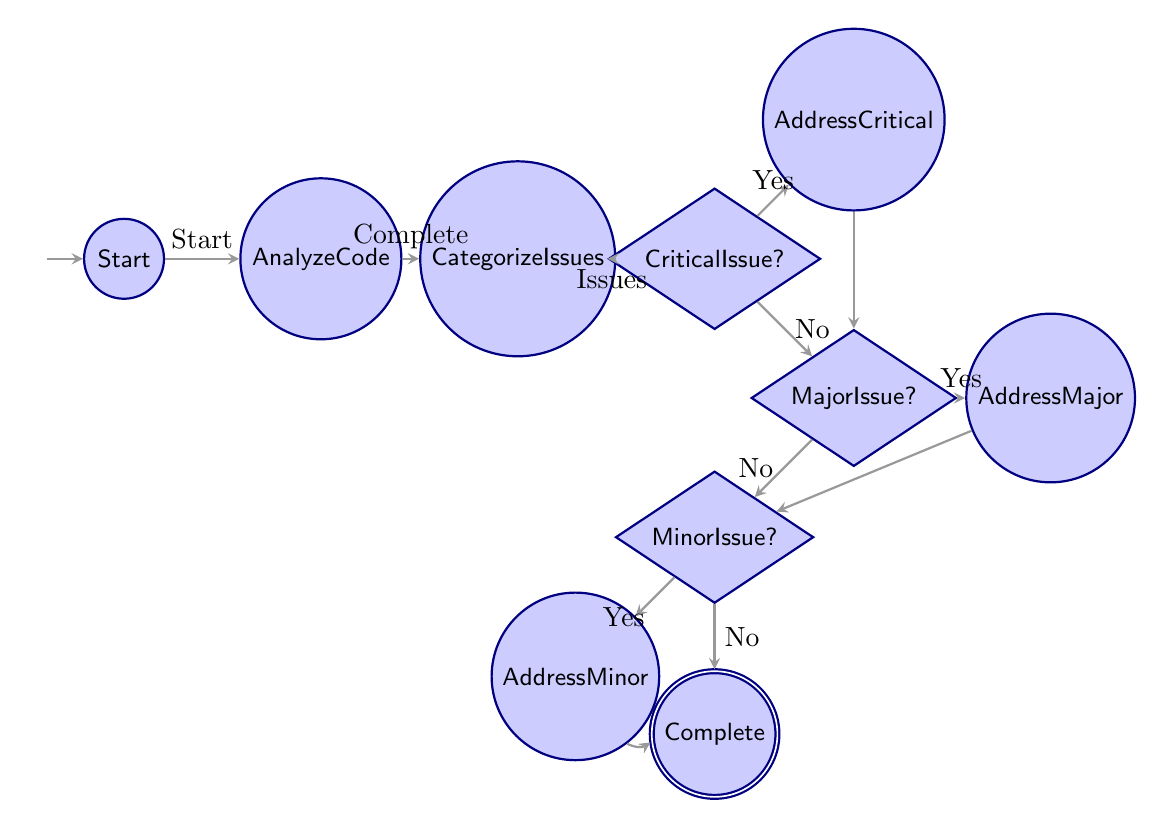What is the initial state of the code review process? The diagram shows that the initial state is labeled as "Start".
Answer: Start How many decision nodes are present in the diagram? The diagram contains three decision nodes: "Critical Issue", "Major Issue", and "Minor Issue".
Answer: 3 What happens if no critical issues are found? If no critical issues are found, the flow proceeds to the "Major Issue" decision node.
Answer: Major Issue What is the end state of the code review process? The final state, indicating completion of the process, is labeled "Code Review Complete".
Answer: Code Review Complete If critical issues are found and addressed, which node does it transition to? After addressing critical issues, the flow transitions to the "Major Issue" decision node.
Answer: Major Issue What is the relationship between "MinorIssue" and "CodeReviewComplete"? "MinorIssue" leads to "CodeReviewComplete" if no minor issues are found.
Answer: Leads to How many process nodes are there in total? The process nodes in the diagram are "Analyze Code", "Categorize Issues", "Address Critical Issue", "Address Major Issue", and "Address Minor Issue", making a total of five process nodes.
Answer: 5 What is the condition for moving from "MajorIssue" to "MinorIssue"? The transition from "Major Issue" to "Minor Issue" occurs when there are no major issues found.
Answer: No major issues What is the first action taken in the review process? The first action taken in the review process is to "Analyze Code".
Answer: Analyze Code 